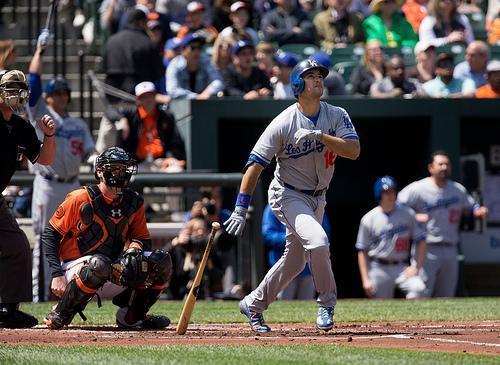How many umpires are therE?
Give a very brief answer. 1. 